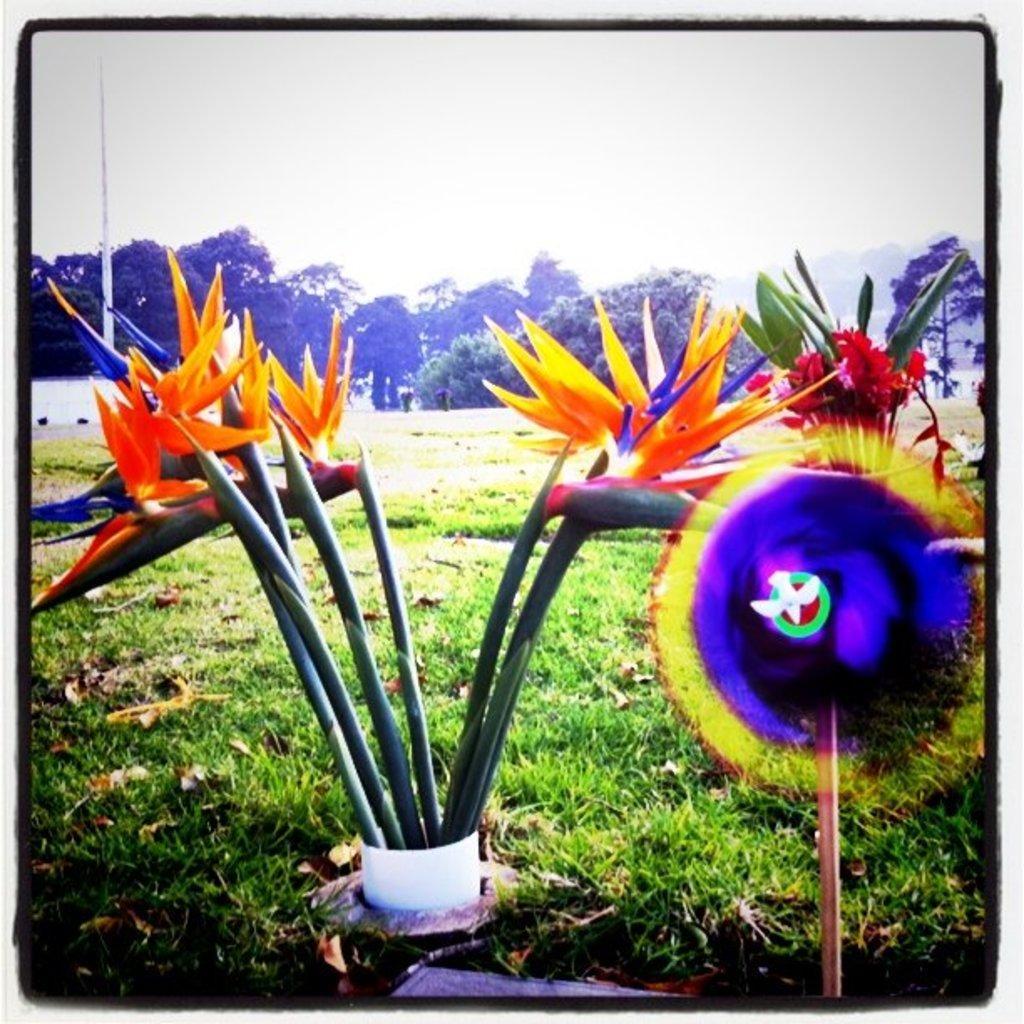In one or two sentences, can you explain what this image depicts? In this image at the bottom, there are plants, flowers, grass. In the background there are trees and sky. 